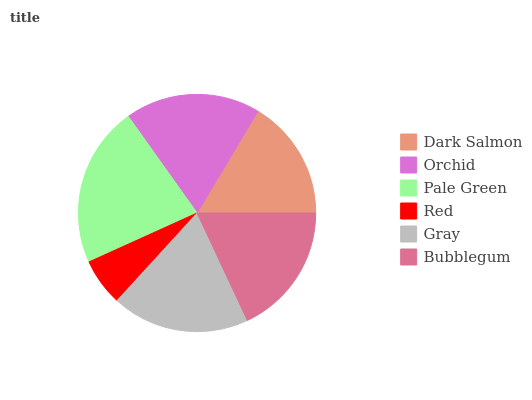Is Red the minimum?
Answer yes or no. Yes. Is Pale Green the maximum?
Answer yes or no. Yes. Is Orchid the minimum?
Answer yes or no. No. Is Orchid the maximum?
Answer yes or no. No. Is Orchid greater than Dark Salmon?
Answer yes or no. Yes. Is Dark Salmon less than Orchid?
Answer yes or no. Yes. Is Dark Salmon greater than Orchid?
Answer yes or no. No. Is Orchid less than Dark Salmon?
Answer yes or no. No. Is Orchid the high median?
Answer yes or no. Yes. Is Bubblegum the low median?
Answer yes or no. Yes. Is Gray the high median?
Answer yes or no. No. Is Red the low median?
Answer yes or no. No. 